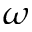Convert formula to latex. <formula><loc_0><loc_0><loc_500><loc_500>\omega</formula> 